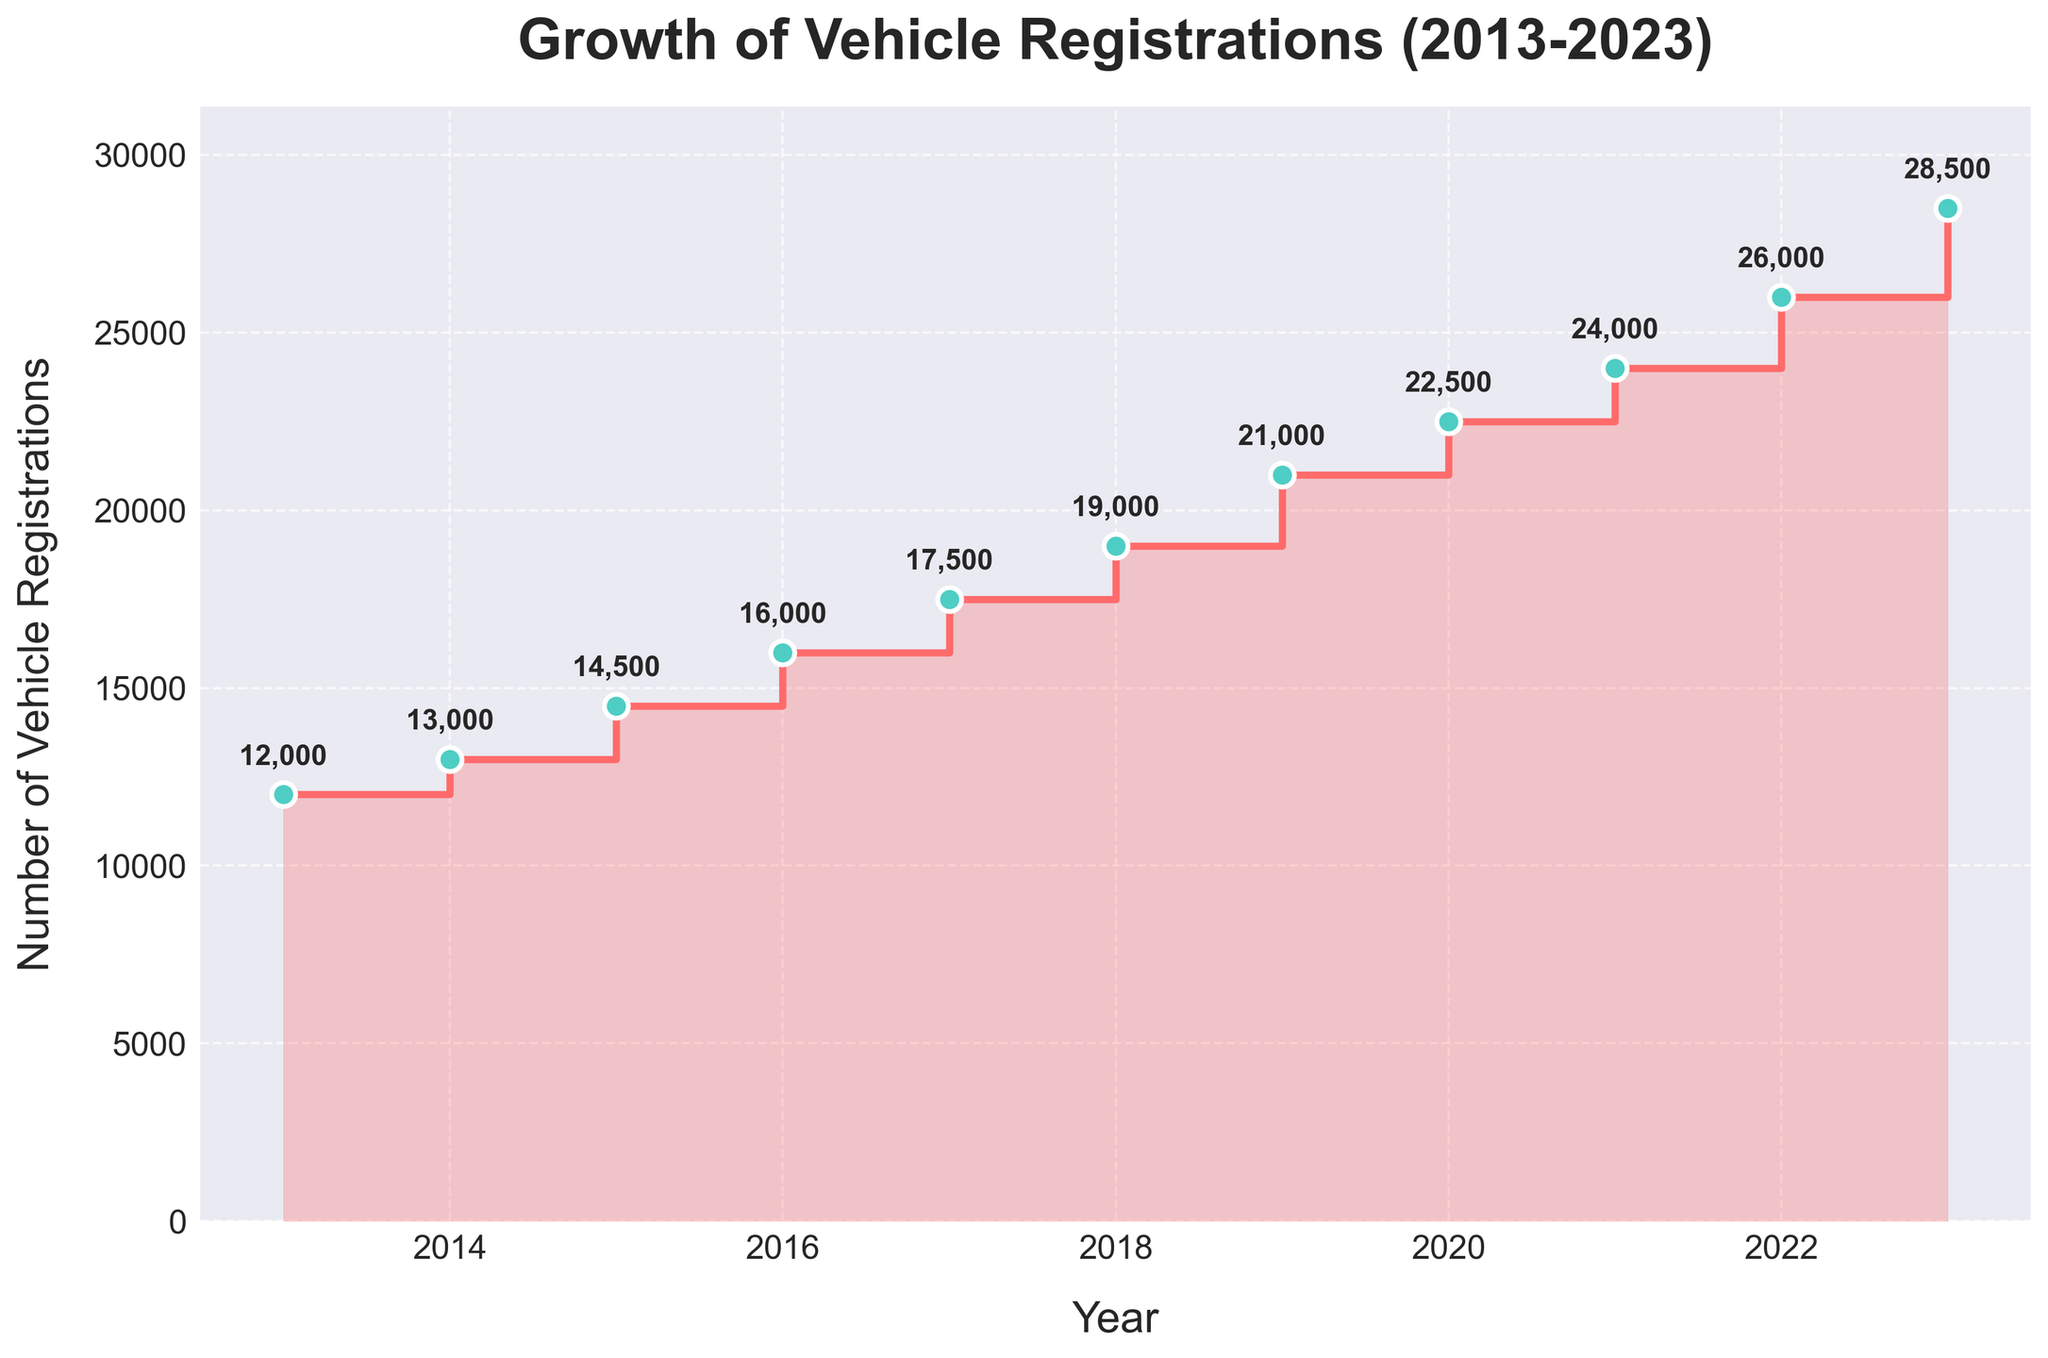How many vehicle registrations were recorded in 2018? Look at the data point corresponding to the year 2018 on the plot. The registration value is annotated on the plot.
Answer: 19,000 What's the growth in vehicle registrations from 2013 to 2016? Subtract the number of vehicle registrations in 2013 from that in 2016 (16,000 - 12,000).
Answer: 4,000 Which year saw the largest increase in vehicle registrations compared to the previous year? Compare the year-over-year changes visually on the plot. The year with the highest vertical step indicates the largest increase.
Answer: 2023 How many years had vehicle registrations that were 20,000 or higher? Count the number of years from the plot where the annotations show values of 20,000 or higher.
Answer: 4 years (2019, 2020, 2021, 2022, 2023) What's the average annual growth in vehicle registrations from 2013 to 2023? Find the total growth over the period (28,500 - 12,000 = 16,500) and then divide by the number of years (2023 - 2013 = 10 years).
Answer: 1,650 According to the figure, did vehicle registrations in 2017 exceed those in 2015? Compare the annotations for 2017 and 2015 on the plot.
Answer: Yes How much did vehicle registrations increase between 2019 and 2022? Subtract the number of vehicle registrations in 2019 from that in 2022 (26,000 - 21,000).
Answer: 5,000 What is the percentage increase in vehicle registrations from 2015 to 2023? First, find the increase in registrations (28,500 - 14,500 = 14,000). Then, calculate the percentage increase relative to 2015 ((14,000 / 14,500) * 100).
Answer: 96.6% What's the total number of vehicle registrations recorded from 2013 to 2023? Sum the vehicle registrations for each year: 12000 + 13000 + 14500 + 16000 + 17500 + 19000 + 21000 + 22500 + 24000 + 26000 + 28500.
Answer: 203,500 Why might the city experience increasing traffic congestion given the trend in vehicle registrations? The plot shows a consistent increase in vehicle registrations every year, indicating more vehicles on the road each year, potentially leading to more traffic congestion.
Answer: Increasing vehicle registrations 